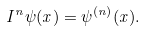Convert formula to latex. <formula><loc_0><loc_0><loc_500><loc_500>I ^ { n } \psi ( x ) = \psi ^ { ( n ) } ( x ) .</formula> 